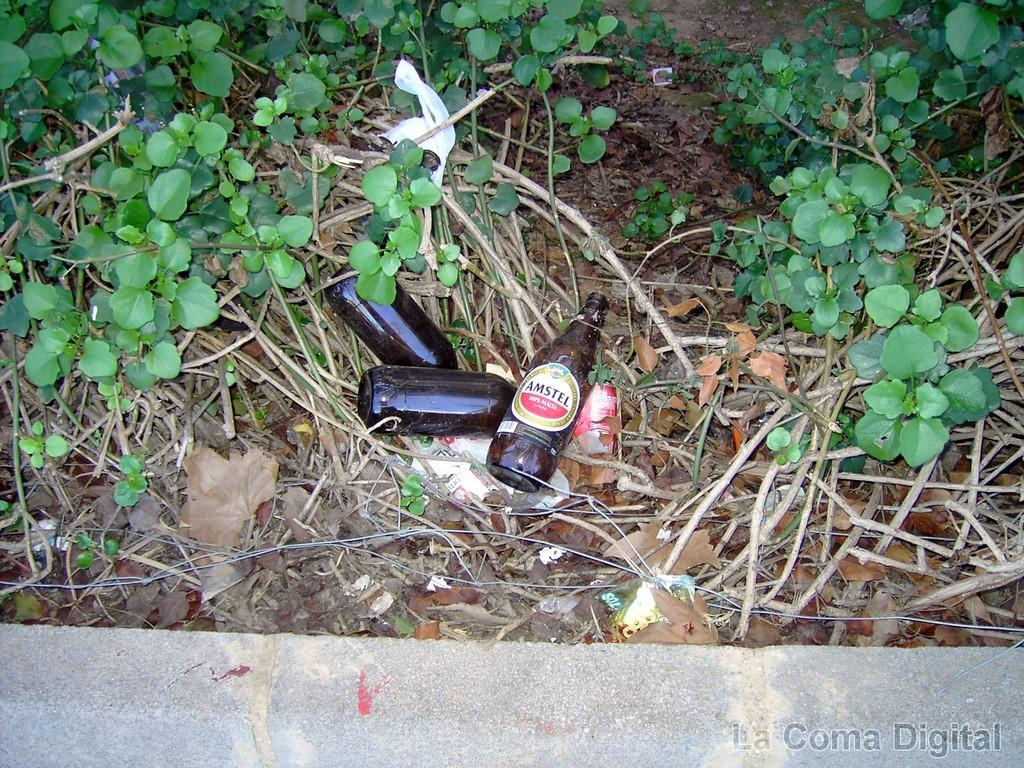How many bottles are on the floor in the image? There are 3 bottles on the floor in the image. What else can be seen in the image besides the bottles? There are plants in the image. What type of cattle can be seen grazing near the bottles in the image? There are no cattle present in the image; it only features 3 bottles on the floor and plants. 